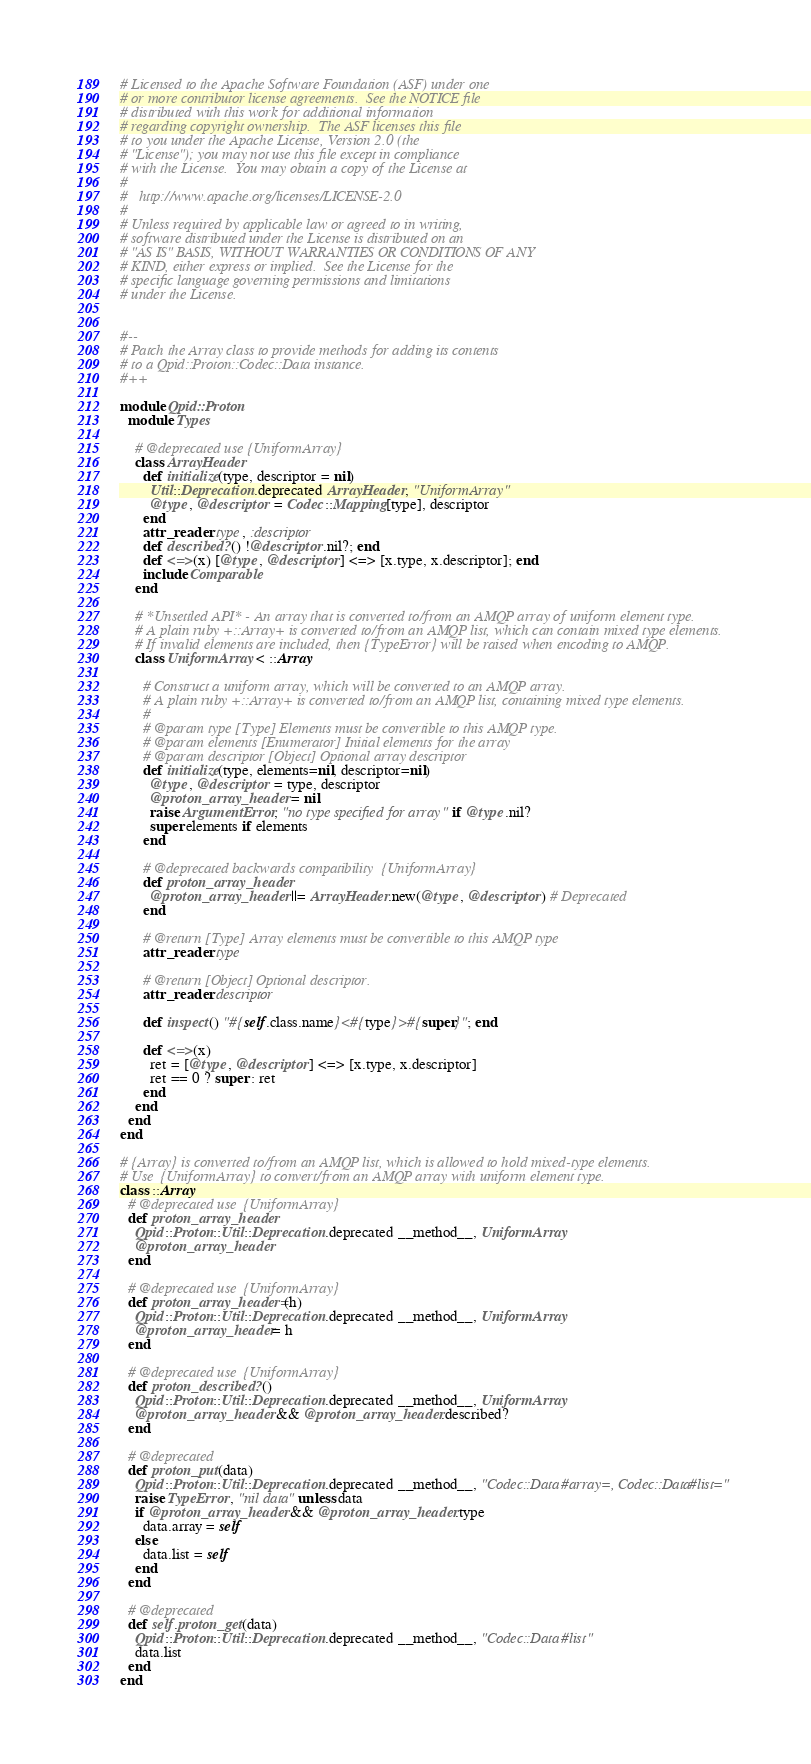<code> <loc_0><loc_0><loc_500><loc_500><_Ruby_># Licensed to the Apache Software Foundation (ASF) under one
# or more contributor license agreements.  See the NOTICE file
# distributed with this work for additional information
# regarding copyright ownership.  The ASF licenses this file
# to you under the Apache License, Version 2.0 (the
# "License"); you may not use this file except in compliance
# with the License.  You may obtain a copy of the License at
#
#   http://www.apache.org/licenses/LICENSE-2.0
#
# Unless required by applicable law or agreed to in writing,
# software distributed under the License is distributed on an
# "AS IS" BASIS, WITHOUT WARRANTIES OR CONDITIONS OF ANY
# KIND, either express or implied.  See the License for the
# specific language governing permissions and limitations
# under the License.


#--
# Patch the Array class to provide methods for adding its contents
# to a Qpid::Proton::Codec::Data instance.
#++

module Qpid::Proton
  module Types

    # @deprecated use {UniformArray}
    class ArrayHeader
      def initialize(type, descriptor = nil)
        Util::Deprecation.deprecated ArrayHeader, "UniformArray"
        @type, @descriptor = Codec::Mapping[type], descriptor
      end
      attr_reader :type, :descriptor
      def described?() !@descriptor.nil?; end
      def <=>(x) [@type, @descriptor] <=> [x.type, x.descriptor]; end
      include Comparable
    end

    # *Unsettled API* - An array that is converted to/from an AMQP array of uniform element type.
    # A plain ruby +::Array+ is converted to/from an AMQP list, which can contain mixed type elements.
    # If invalid elements are included, then {TypeError} will be raised when encoding to AMQP.
    class UniformArray < ::Array

      # Construct a uniform array, which will be converted to an AMQP array.
      # A plain ruby +::Array+ is converted to/from an AMQP list, containing mixed type elements.
      #
      # @param type [Type] Elements must be convertible to this AMQP type.
      # @param elements [Enumerator] Initial elements for the array
      # @param descriptor [Object] Optional array descriptor
      def initialize(type, elements=nil, descriptor=nil)
        @type, @descriptor = type, descriptor
        @proton_array_header = nil
        raise ArgumentError, "no type specified for array" if @type.nil?
        super elements if elements
      end

      # @deprecated backwards compatibility  {UniformArray}
      def proton_array_header
        @proton_array_header ||= ArrayHeader.new(@type, @descriptor) # Deprecated
      end

      # @return [Type] Array elements must be convertible to this AMQP type
      attr_reader :type

      # @return [Object] Optional descriptor.
      attr_reader :descriptor

      def inspect() "#{self.class.name}<#{type}>#{super}"; end

      def <=>(x)
        ret = [@type, @descriptor] <=> [x.type, x.descriptor]
        ret == 0 ? super : ret
      end
    end
  end
end

# {Array} is converted to/from an AMQP list, which is allowed to hold mixed-type elements.
# Use  {UniformArray} to convert/from an AMQP array with uniform element type.
class ::Array
  # @deprecated use  {UniformArray}
  def proton_array_header
    Qpid::Proton::Util::Deprecation.deprecated __method__, UniformArray
    @proton_array_header
  end

  # @deprecated use  {UniformArray}
  def proton_array_header=(h)
    Qpid::Proton::Util::Deprecation.deprecated __method__, UniformArray
    @proton_array_header= h
  end

  # @deprecated use  {UniformArray}
  def proton_described?()
    Qpid::Proton::Util::Deprecation.deprecated __method__, UniformArray
    @proton_array_header && @proton_array_header.described?
  end

  # @deprecated
  def proton_put(data)
    Qpid::Proton::Util::Deprecation.deprecated __method__, "Codec::Data#array=, Codec::Data#list="
    raise TypeError, "nil data" unless data
    if @proton_array_header && @proton_array_header.type
      data.array = self
    else
      data.list = self
    end
  end

  # @deprecated
  def self.proton_get(data)
    Qpid::Proton::Util::Deprecation.deprecated __method__, "Codec::Data#list"
    data.list
  end
end

</code> 